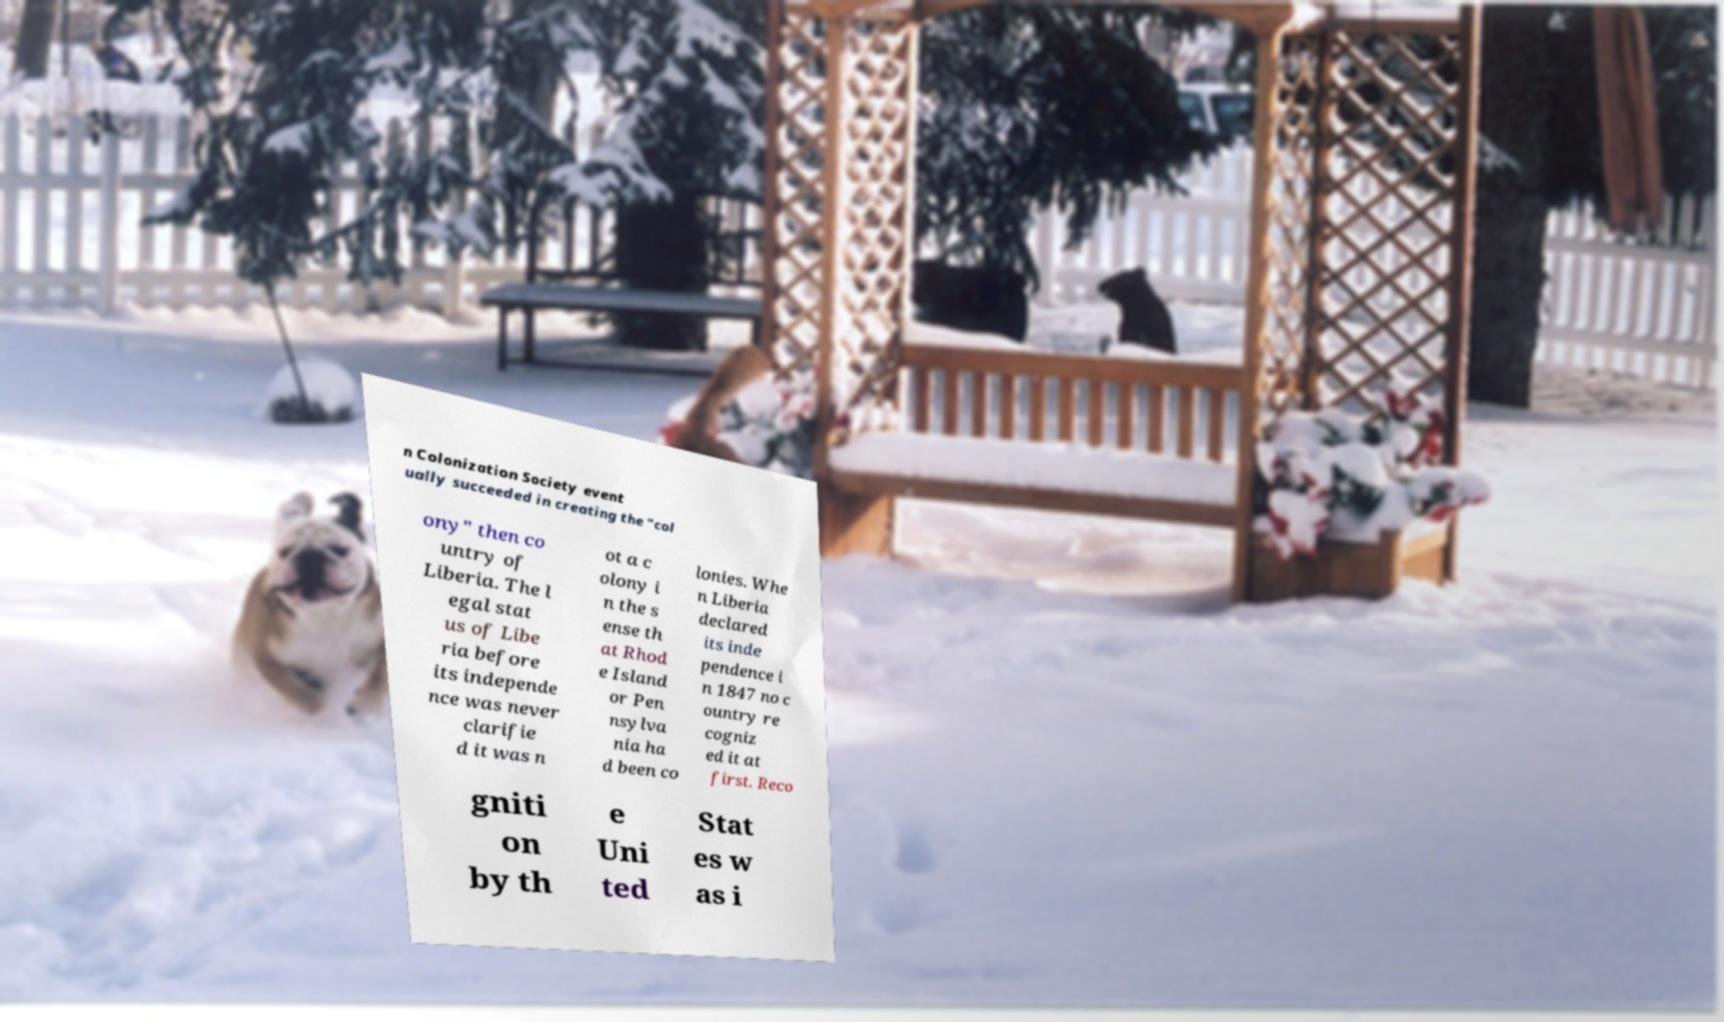Could you extract and type out the text from this image? n Colonization Society event ually succeeded in creating the "col ony" then co untry of Liberia. The l egal stat us of Libe ria before its independe nce was never clarifie d it was n ot a c olony i n the s ense th at Rhod e Island or Pen nsylva nia ha d been co lonies. Whe n Liberia declared its inde pendence i n 1847 no c ountry re cogniz ed it at first. Reco gniti on by th e Uni ted Stat es w as i 